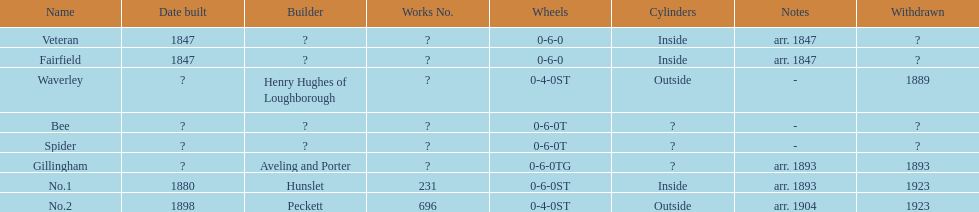What is the complete sum of names listed on the chart? 8. 